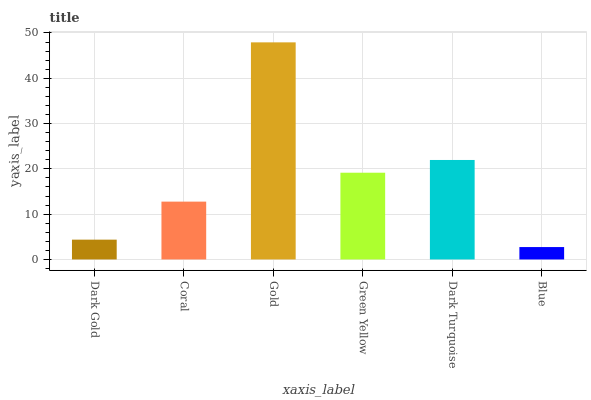Is Coral the minimum?
Answer yes or no. No. Is Coral the maximum?
Answer yes or no. No. Is Coral greater than Dark Gold?
Answer yes or no. Yes. Is Dark Gold less than Coral?
Answer yes or no. Yes. Is Dark Gold greater than Coral?
Answer yes or no. No. Is Coral less than Dark Gold?
Answer yes or no. No. Is Green Yellow the high median?
Answer yes or no. Yes. Is Coral the low median?
Answer yes or no. Yes. Is Dark Turquoise the high median?
Answer yes or no. No. Is Blue the low median?
Answer yes or no. No. 